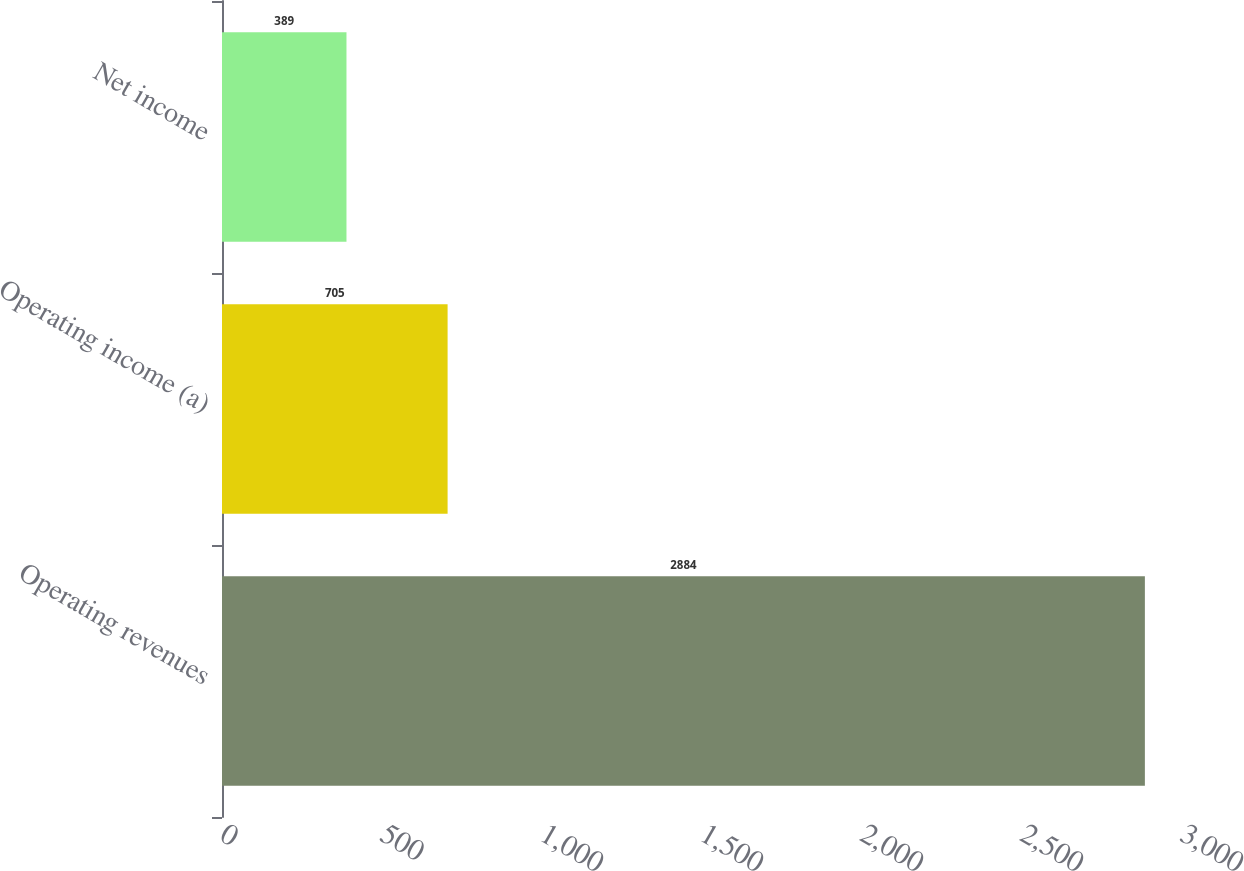<chart> <loc_0><loc_0><loc_500><loc_500><bar_chart><fcel>Operating revenues<fcel>Operating income (a)<fcel>Net income<nl><fcel>2884<fcel>705<fcel>389<nl></chart> 